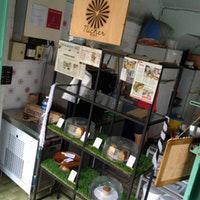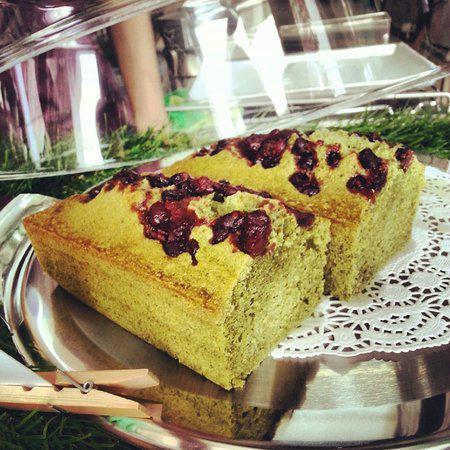The first image is the image on the left, the second image is the image on the right. For the images displayed, is the sentence "One of the shops advertises 'dough & grains'." factually correct? Answer yes or no. No. The first image is the image on the left, the second image is the image on the right. For the images displayed, is the sentence "The left image features tiered shelves behind a glass case filled with side-by-side rectangular trays of baked goods, each with an oval cut-out tray handle facing the glass front." factually correct? Answer yes or no. No. 